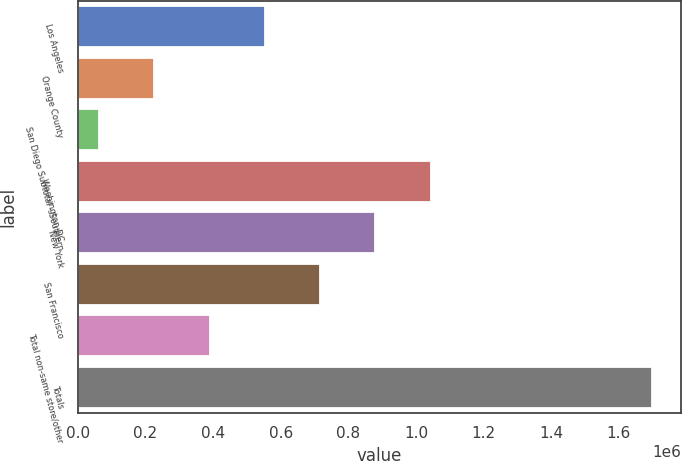Convert chart. <chart><loc_0><loc_0><loc_500><loc_500><bar_chart><fcel>Los Angeles<fcel>Orange County<fcel>San Diego Subtotal - Southern<fcel>Washington DC<fcel>New York<fcel>San Francisco<fcel>Total non-same store/other<fcel>Totals<nl><fcel>553003<fcel>225854<fcel>62280<fcel>1.04373e+06<fcel>880152<fcel>716577<fcel>389429<fcel>1.69802e+06<nl></chart> 